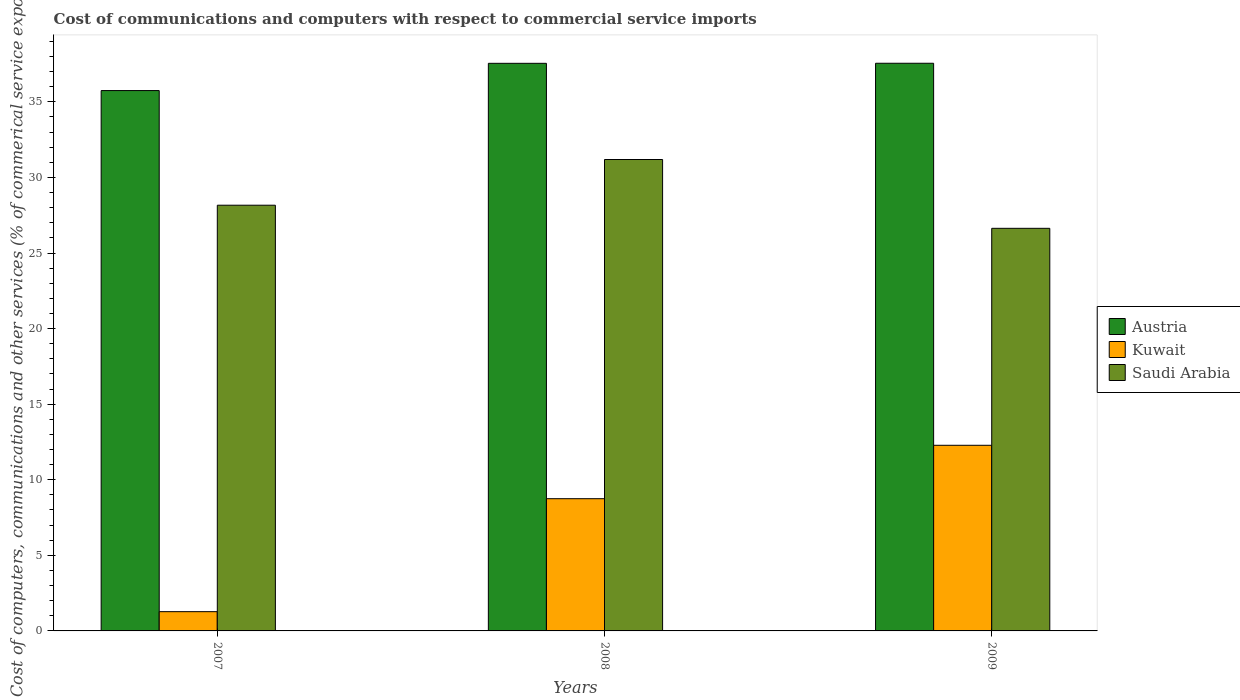How many bars are there on the 2nd tick from the left?
Provide a short and direct response. 3. What is the label of the 3rd group of bars from the left?
Your response must be concise. 2009. What is the cost of communications and computers in Kuwait in 2009?
Provide a short and direct response. 12.28. Across all years, what is the maximum cost of communications and computers in Kuwait?
Make the answer very short. 12.28. Across all years, what is the minimum cost of communications and computers in Austria?
Make the answer very short. 35.75. In which year was the cost of communications and computers in Austria minimum?
Offer a terse response. 2007. What is the total cost of communications and computers in Kuwait in the graph?
Offer a very short reply. 22.3. What is the difference between the cost of communications and computers in Saudi Arabia in 2008 and that in 2009?
Ensure brevity in your answer.  4.55. What is the difference between the cost of communications and computers in Austria in 2008 and the cost of communications and computers in Kuwait in 2007?
Provide a short and direct response. 36.27. What is the average cost of communications and computers in Austria per year?
Your answer should be very brief. 36.95. In the year 2009, what is the difference between the cost of communications and computers in Saudi Arabia and cost of communications and computers in Kuwait?
Your answer should be compact. 14.35. In how many years, is the cost of communications and computers in Saudi Arabia greater than 11 %?
Ensure brevity in your answer.  3. What is the ratio of the cost of communications and computers in Austria in 2007 to that in 2009?
Offer a terse response. 0.95. Is the cost of communications and computers in Austria in 2008 less than that in 2009?
Give a very brief answer. Yes. Is the difference between the cost of communications and computers in Saudi Arabia in 2007 and 2009 greater than the difference between the cost of communications and computers in Kuwait in 2007 and 2009?
Ensure brevity in your answer.  Yes. What is the difference between the highest and the second highest cost of communications and computers in Austria?
Ensure brevity in your answer.  0. What is the difference between the highest and the lowest cost of communications and computers in Austria?
Your response must be concise. 1.81. Is the sum of the cost of communications and computers in Saudi Arabia in 2007 and 2008 greater than the maximum cost of communications and computers in Austria across all years?
Provide a short and direct response. Yes. What does the 3rd bar from the left in 2007 represents?
Offer a very short reply. Saudi Arabia. What does the 3rd bar from the right in 2007 represents?
Your answer should be very brief. Austria. Is it the case that in every year, the sum of the cost of communications and computers in Saudi Arabia and cost of communications and computers in Kuwait is greater than the cost of communications and computers in Austria?
Offer a terse response. No. How many bars are there?
Your answer should be very brief. 9. What is the difference between two consecutive major ticks on the Y-axis?
Provide a short and direct response. 5. Where does the legend appear in the graph?
Make the answer very short. Center right. How are the legend labels stacked?
Ensure brevity in your answer.  Vertical. What is the title of the graph?
Your answer should be very brief. Cost of communications and computers with respect to commercial service imports. What is the label or title of the Y-axis?
Make the answer very short. Cost of computers, communications and other services (% of commerical service exports). What is the Cost of computers, communications and other services (% of commerical service exports) of Austria in 2007?
Provide a short and direct response. 35.75. What is the Cost of computers, communications and other services (% of commerical service exports) in Kuwait in 2007?
Keep it short and to the point. 1.27. What is the Cost of computers, communications and other services (% of commerical service exports) of Saudi Arabia in 2007?
Ensure brevity in your answer.  28.16. What is the Cost of computers, communications and other services (% of commerical service exports) of Austria in 2008?
Your response must be concise. 37.55. What is the Cost of computers, communications and other services (% of commerical service exports) of Kuwait in 2008?
Your response must be concise. 8.75. What is the Cost of computers, communications and other services (% of commerical service exports) of Saudi Arabia in 2008?
Make the answer very short. 31.19. What is the Cost of computers, communications and other services (% of commerical service exports) in Austria in 2009?
Provide a short and direct response. 37.55. What is the Cost of computers, communications and other services (% of commerical service exports) of Kuwait in 2009?
Provide a succinct answer. 12.28. What is the Cost of computers, communications and other services (% of commerical service exports) in Saudi Arabia in 2009?
Offer a terse response. 26.63. Across all years, what is the maximum Cost of computers, communications and other services (% of commerical service exports) of Austria?
Give a very brief answer. 37.55. Across all years, what is the maximum Cost of computers, communications and other services (% of commerical service exports) in Kuwait?
Offer a very short reply. 12.28. Across all years, what is the maximum Cost of computers, communications and other services (% of commerical service exports) in Saudi Arabia?
Your answer should be compact. 31.19. Across all years, what is the minimum Cost of computers, communications and other services (% of commerical service exports) of Austria?
Give a very brief answer. 35.75. Across all years, what is the minimum Cost of computers, communications and other services (% of commerical service exports) of Kuwait?
Your response must be concise. 1.27. Across all years, what is the minimum Cost of computers, communications and other services (% of commerical service exports) in Saudi Arabia?
Your answer should be very brief. 26.63. What is the total Cost of computers, communications and other services (% of commerical service exports) in Austria in the graph?
Give a very brief answer. 110.85. What is the total Cost of computers, communications and other services (% of commerical service exports) of Kuwait in the graph?
Give a very brief answer. 22.3. What is the total Cost of computers, communications and other services (% of commerical service exports) in Saudi Arabia in the graph?
Your response must be concise. 85.98. What is the difference between the Cost of computers, communications and other services (% of commerical service exports) in Austria in 2007 and that in 2008?
Keep it short and to the point. -1.8. What is the difference between the Cost of computers, communications and other services (% of commerical service exports) in Kuwait in 2007 and that in 2008?
Offer a very short reply. -7.47. What is the difference between the Cost of computers, communications and other services (% of commerical service exports) of Saudi Arabia in 2007 and that in 2008?
Keep it short and to the point. -3.02. What is the difference between the Cost of computers, communications and other services (% of commerical service exports) in Austria in 2007 and that in 2009?
Offer a very short reply. -1.81. What is the difference between the Cost of computers, communications and other services (% of commerical service exports) of Kuwait in 2007 and that in 2009?
Keep it short and to the point. -11.01. What is the difference between the Cost of computers, communications and other services (% of commerical service exports) of Saudi Arabia in 2007 and that in 2009?
Provide a short and direct response. 1.53. What is the difference between the Cost of computers, communications and other services (% of commerical service exports) of Austria in 2008 and that in 2009?
Make the answer very short. -0. What is the difference between the Cost of computers, communications and other services (% of commerical service exports) of Kuwait in 2008 and that in 2009?
Provide a short and direct response. -3.53. What is the difference between the Cost of computers, communications and other services (% of commerical service exports) in Saudi Arabia in 2008 and that in 2009?
Offer a very short reply. 4.55. What is the difference between the Cost of computers, communications and other services (% of commerical service exports) of Austria in 2007 and the Cost of computers, communications and other services (% of commerical service exports) of Kuwait in 2008?
Give a very brief answer. 27. What is the difference between the Cost of computers, communications and other services (% of commerical service exports) of Austria in 2007 and the Cost of computers, communications and other services (% of commerical service exports) of Saudi Arabia in 2008?
Your answer should be compact. 4.56. What is the difference between the Cost of computers, communications and other services (% of commerical service exports) of Kuwait in 2007 and the Cost of computers, communications and other services (% of commerical service exports) of Saudi Arabia in 2008?
Ensure brevity in your answer.  -29.91. What is the difference between the Cost of computers, communications and other services (% of commerical service exports) in Austria in 2007 and the Cost of computers, communications and other services (% of commerical service exports) in Kuwait in 2009?
Provide a succinct answer. 23.47. What is the difference between the Cost of computers, communications and other services (% of commerical service exports) in Austria in 2007 and the Cost of computers, communications and other services (% of commerical service exports) in Saudi Arabia in 2009?
Provide a succinct answer. 9.11. What is the difference between the Cost of computers, communications and other services (% of commerical service exports) of Kuwait in 2007 and the Cost of computers, communications and other services (% of commerical service exports) of Saudi Arabia in 2009?
Offer a terse response. -25.36. What is the difference between the Cost of computers, communications and other services (% of commerical service exports) of Austria in 2008 and the Cost of computers, communications and other services (% of commerical service exports) of Kuwait in 2009?
Make the answer very short. 25.27. What is the difference between the Cost of computers, communications and other services (% of commerical service exports) in Austria in 2008 and the Cost of computers, communications and other services (% of commerical service exports) in Saudi Arabia in 2009?
Offer a terse response. 10.92. What is the difference between the Cost of computers, communications and other services (% of commerical service exports) of Kuwait in 2008 and the Cost of computers, communications and other services (% of commerical service exports) of Saudi Arabia in 2009?
Provide a succinct answer. -17.89. What is the average Cost of computers, communications and other services (% of commerical service exports) in Austria per year?
Ensure brevity in your answer.  36.95. What is the average Cost of computers, communications and other services (% of commerical service exports) in Kuwait per year?
Offer a terse response. 7.43. What is the average Cost of computers, communications and other services (% of commerical service exports) in Saudi Arabia per year?
Your response must be concise. 28.66. In the year 2007, what is the difference between the Cost of computers, communications and other services (% of commerical service exports) of Austria and Cost of computers, communications and other services (% of commerical service exports) of Kuwait?
Offer a terse response. 34.47. In the year 2007, what is the difference between the Cost of computers, communications and other services (% of commerical service exports) of Austria and Cost of computers, communications and other services (% of commerical service exports) of Saudi Arabia?
Your answer should be compact. 7.58. In the year 2007, what is the difference between the Cost of computers, communications and other services (% of commerical service exports) of Kuwait and Cost of computers, communications and other services (% of commerical service exports) of Saudi Arabia?
Offer a very short reply. -26.89. In the year 2008, what is the difference between the Cost of computers, communications and other services (% of commerical service exports) of Austria and Cost of computers, communications and other services (% of commerical service exports) of Kuwait?
Your answer should be very brief. 28.8. In the year 2008, what is the difference between the Cost of computers, communications and other services (% of commerical service exports) in Austria and Cost of computers, communications and other services (% of commerical service exports) in Saudi Arabia?
Give a very brief answer. 6.36. In the year 2008, what is the difference between the Cost of computers, communications and other services (% of commerical service exports) in Kuwait and Cost of computers, communications and other services (% of commerical service exports) in Saudi Arabia?
Ensure brevity in your answer.  -22.44. In the year 2009, what is the difference between the Cost of computers, communications and other services (% of commerical service exports) of Austria and Cost of computers, communications and other services (% of commerical service exports) of Kuwait?
Your response must be concise. 25.27. In the year 2009, what is the difference between the Cost of computers, communications and other services (% of commerical service exports) in Austria and Cost of computers, communications and other services (% of commerical service exports) in Saudi Arabia?
Your response must be concise. 10.92. In the year 2009, what is the difference between the Cost of computers, communications and other services (% of commerical service exports) in Kuwait and Cost of computers, communications and other services (% of commerical service exports) in Saudi Arabia?
Your response must be concise. -14.35. What is the ratio of the Cost of computers, communications and other services (% of commerical service exports) of Austria in 2007 to that in 2008?
Your response must be concise. 0.95. What is the ratio of the Cost of computers, communications and other services (% of commerical service exports) in Kuwait in 2007 to that in 2008?
Ensure brevity in your answer.  0.15. What is the ratio of the Cost of computers, communications and other services (% of commerical service exports) in Saudi Arabia in 2007 to that in 2008?
Ensure brevity in your answer.  0.9. What is the ratio of the Cost of computers, communications and other services (% of commerical service exports) of Austria in 2007 to that in 2009?
Ensure brevity in your answer.  0.95. What is the ratio of the Cost of computers, communications and other services (% of commerical service exports) of Kuwait in 2007 to that in 2009?
Ensure brevity in your answer.  0.1. What is the ratio of the Cost of computers, communications and other services (% of commerical service exports) in Saudi Arabia in 2007 to that in 2009?
Provide a short and direct response. 1.06. What is the ratio of the Cost of computers, communications and other services (% of commerical service exports) in Austria in 2008 to that in 2009?
Offer a terse response. 1. What is the ratio of the Cost of computers, communications and other services (% of commerical service exports) of Kuwait in 2008 to that in 2009?
Ensure brevity in your answer.  0.71. What is the ratio of the Cost of computers, communications and other services (% of commerical service exports) in Saudi Arabia in 2008 to that in 2009?
Offer a terse response. 1.17. What is the difference between the highest and the second highest Cost of computers, communications and other services (% of commerical service exports) in Austria?
Your answer should be compact. 0. What is the difference between the highest and the second highest Cost of computers, communications and other services (% of commerical service exports) in Kuwait?
Offer a terse response. 3.53. What is the difference between the highest and the second highest Cost of computers, communications and other services (% of commerical service exports) in Saudi Arabia?
Your response must be concise. 3.02. What is the difference between the highest and the lowest Cost of computers, communications and other services (% of commerical service exports) in Austria?
Your response must be concise. 1.81. What is the difference between the highest and the lowest Cost of computers, communications and other services (% of commerical service exports) of Kuwait?
Ensure brevity in your answer.  11.01. What is the difference between the highest and the lowest Cost of computers, communications and other services (% of commerical service exports) in Saudi Arabia?
Give a very brief answer. 4.55. 